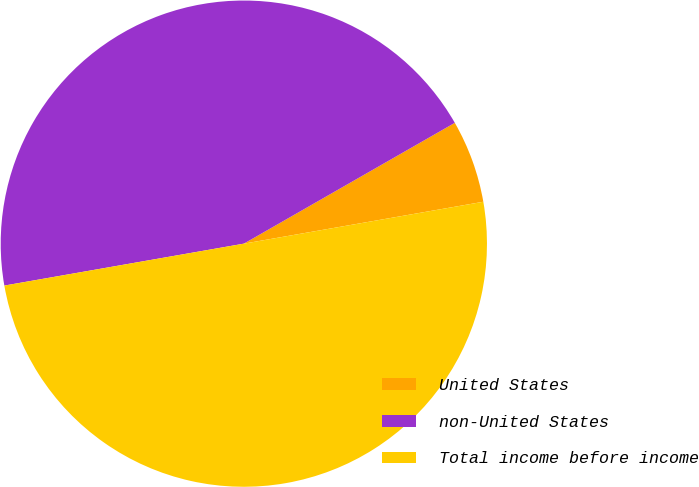Convert chart. <chart><loc_0><loc_0><loc_500><loc_500><pie_chart><fcel>United States<fcel>non-United States<fcel>Total income before income<nl><fcel>5.52%<fcel>44.48%<fcel>50.0%<nl></chart> 